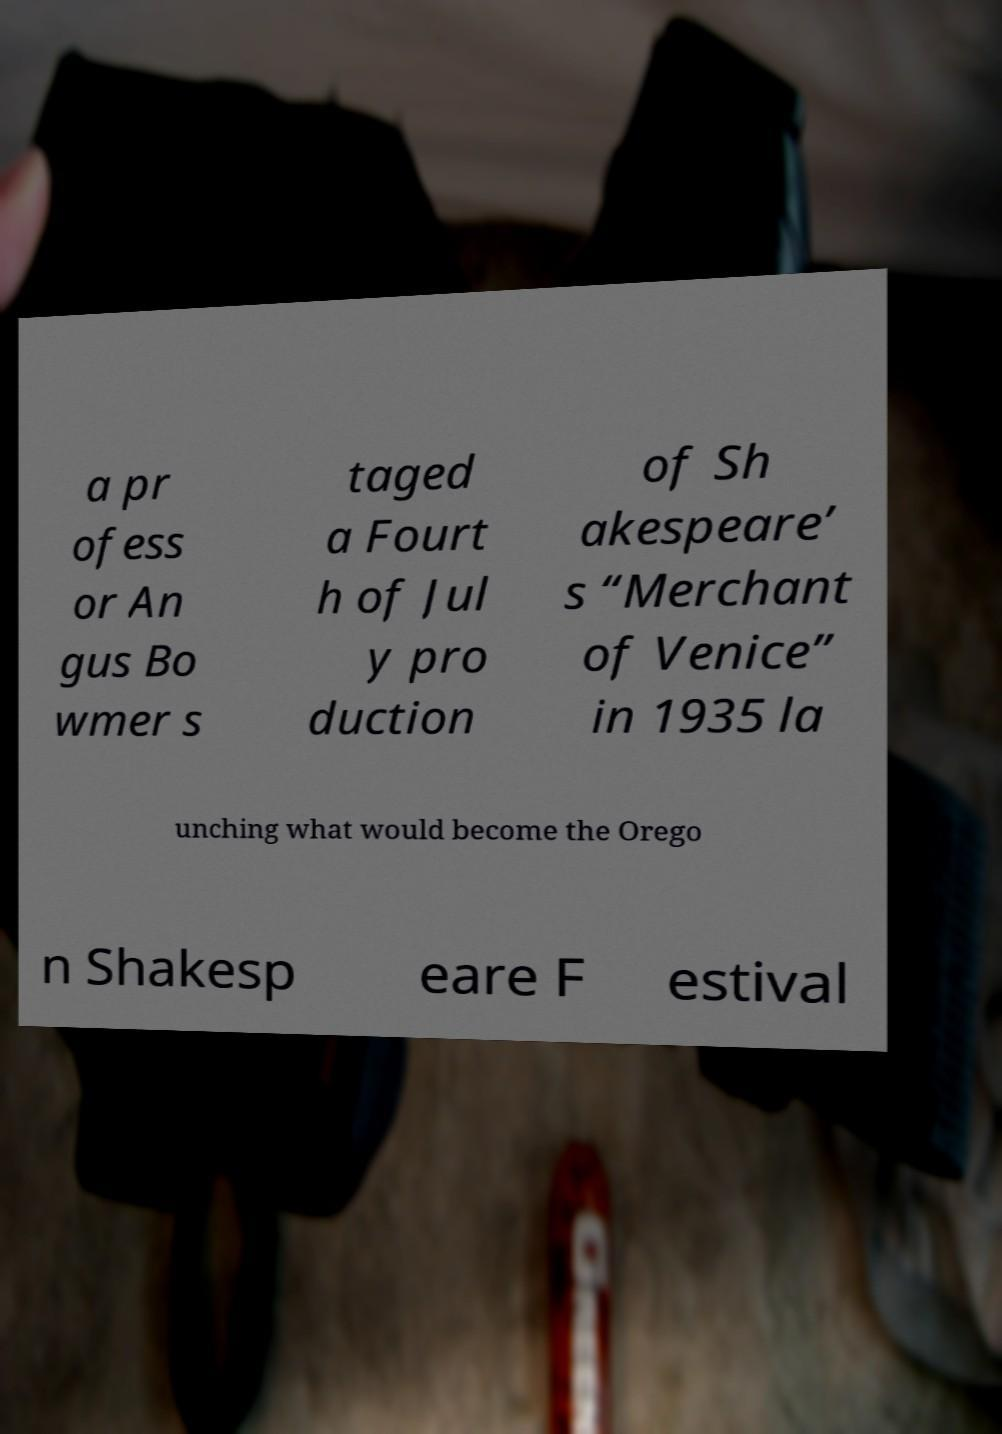For documentation purposes, I need the text within this image transcribed. Could you provide that? a pr ofess or An gus Bo wmer s taged a Fourt h of Jul y pro duction of Sh akespeare’ s “Merchant of Venice” in 1935 la unching what would become the Orego n Shakesp eare F estival 